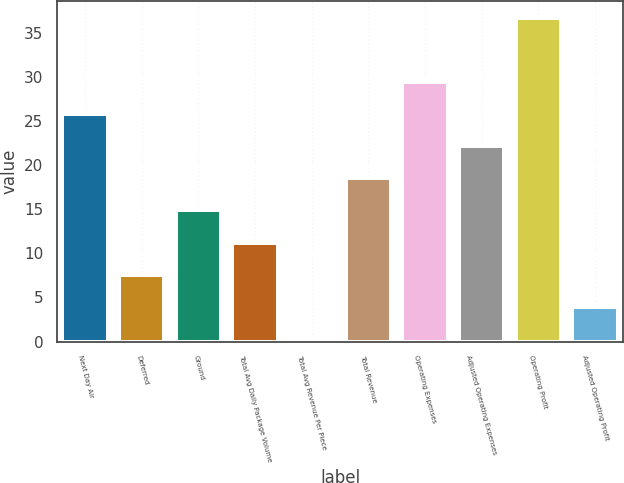Convert chart. <chart><loc_0><loc_0><loc_500><loc_500><bar_chart><fcel>Next Day Air<fcel>Deferred<fcel>Ground<fcel>Total Avg Daily Package Volume<fcel>Total Avg Revenue Per Piece<fcel>Total Revenue<fcel>Operating Expenses<fcel>Adjusted Operating Expenses<fcel>Operating Profit<fcel>Adjusted Operating Profit<nl><fcel>25.78<fcel>7.58<fcel>14.86<fcel>11.22<fcel>0.3<fcel>18.5<fcel>29.42<fcel>22.14<fcel>36.7<fcel>3.94<nl></chart> 